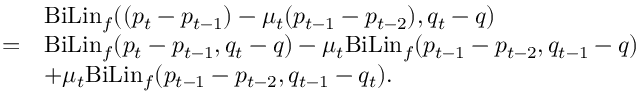<formula> <loc_0><loc_0><loc_500><loc_500>\begin{array} { r l } & { B i L i n _ { f } ( ( p _ { t } - p _ { t - 1 } ) - \mu _ { t } ( p _ { t - 1 } - p _ { t - 2 } ) , q _ { t } - q ) } \\ { = } & { B i L i n _ { f } ( p _ { t } - p _ { t - 1 } , q _ { t } - q ) - \mu _ { t } B i L i n _ { f } ( p _ { t - 1 } - p _ { t - 2 } , q _ { t - 1 } - q ) } \\ & { + \mu _ { t } B i L i n _ { f } ( p _ { t - 1 } - p _ { t - 2 } , q _ { t - 1 } - q _ { t } ) . } \end{array}</formula> 